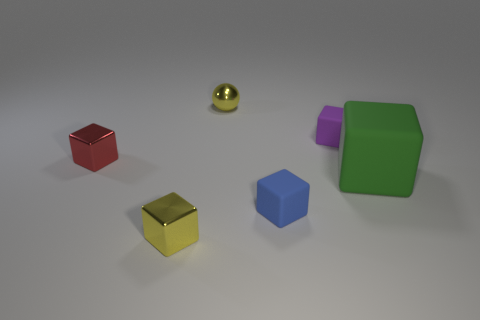How many blue balls are there?
Your answer should be very brief. 0. What shape is the yellow shiny thing that is behind the tiny shiny cube behind the green cube?
Your answer should be very brief. Sphere. What number of tiny cubes are to the right of the big matte object?
Your answer should be very brief. 0. Are the tiny blue object and the purple thing to the left of the big green block made of the same material?
Make the answer very short. Yes. Is there a green matte cube that has the same size as the yellow shiny cube?
Provide a succinct answer. No. Are there an equal number of large green rubber objects behind the large matte cube and yellow metallic balls?
Keep it short and to the point. No. The blue rubber block has what size?
Your answer should be very brief. Small. There is a small yellow object on the left side of the sphere; how many small purple things are to the left of it?
Make the answer very short. 0. What shape is the small object that is behind the blue rubber cube and right of the yellow metallic ball?
Your answer should be very brief. Cube. What number of tiny rubber things have the same color as the tiny shiny ball?
Provide a short and direct response. 0. 